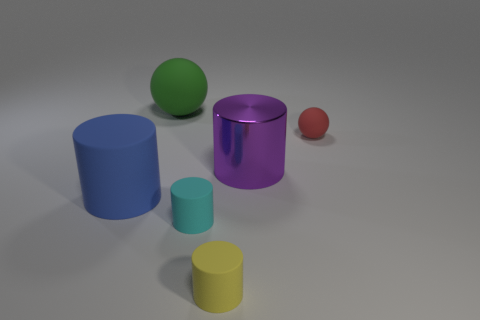Subtract all purple cylinders. How many cylinders are left? 3 Subtract all yellow cylinders. How many cylinders are left? 3 Subtract 2 cylinders. How many cylinders are left? 2 Subtract all cylinders. How many objects are left? 2 Subtract all cyan balls. Subtract all brown cubes. How many balls are left? 2 Subtract all green blocks. How many red spheres are left? 1 Subtract all balls. Subtract all green rubber spheres. How many objects are left? 3 Add 6 blue objects. How many blue objects are left? 7 Add 3 big cyan matte blocks. How many big cyan matte blocks exist? 3 Add 1 big matte objects. How many objects exist? 7 